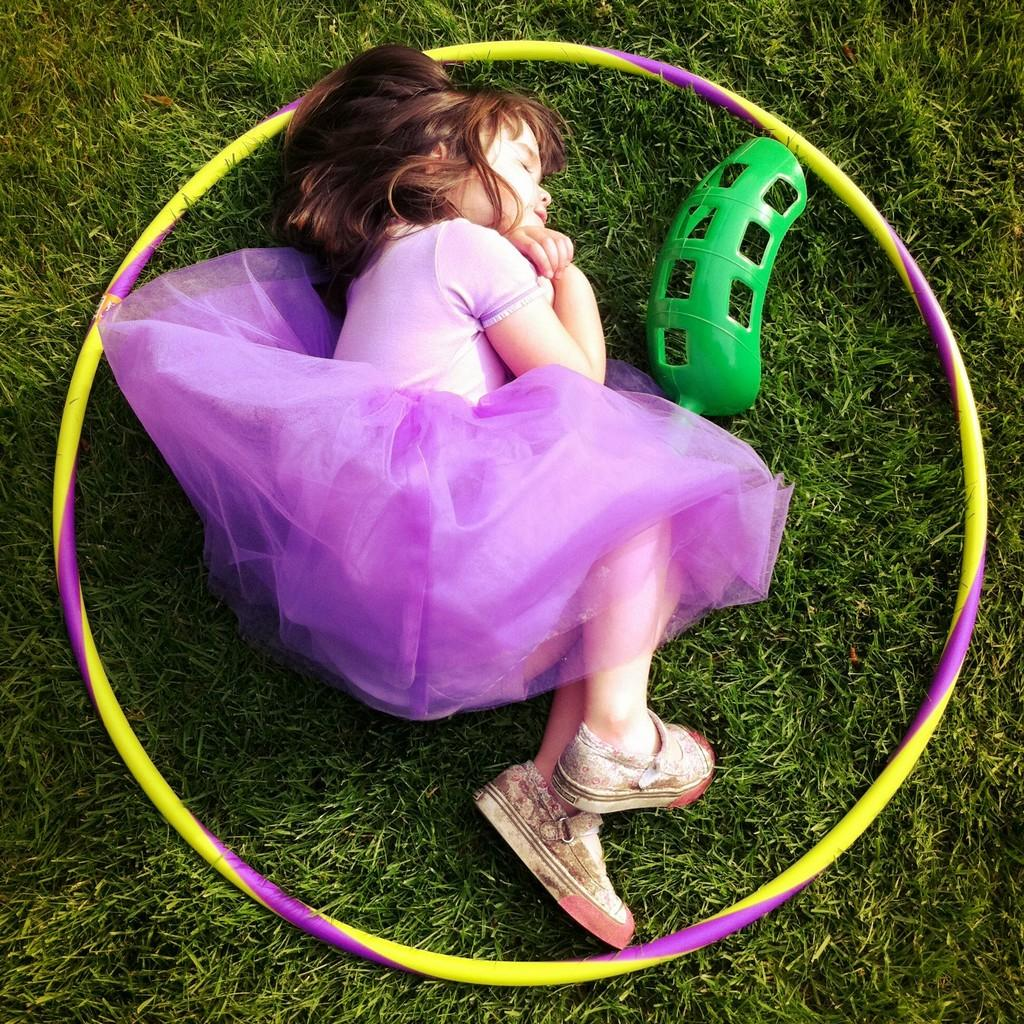Who is the main subject in the image? There is a girl in the image. What is inside the hula hoop ring in the image? There is a decor inside a hula hoop ring in the image. Where is the hula hoop ring and its contents placed? The hula hoop ring and its contents are placed on the grass. What type of glove is the girl wearing while reading in the image? There is no glove or reading activity present in the image. 